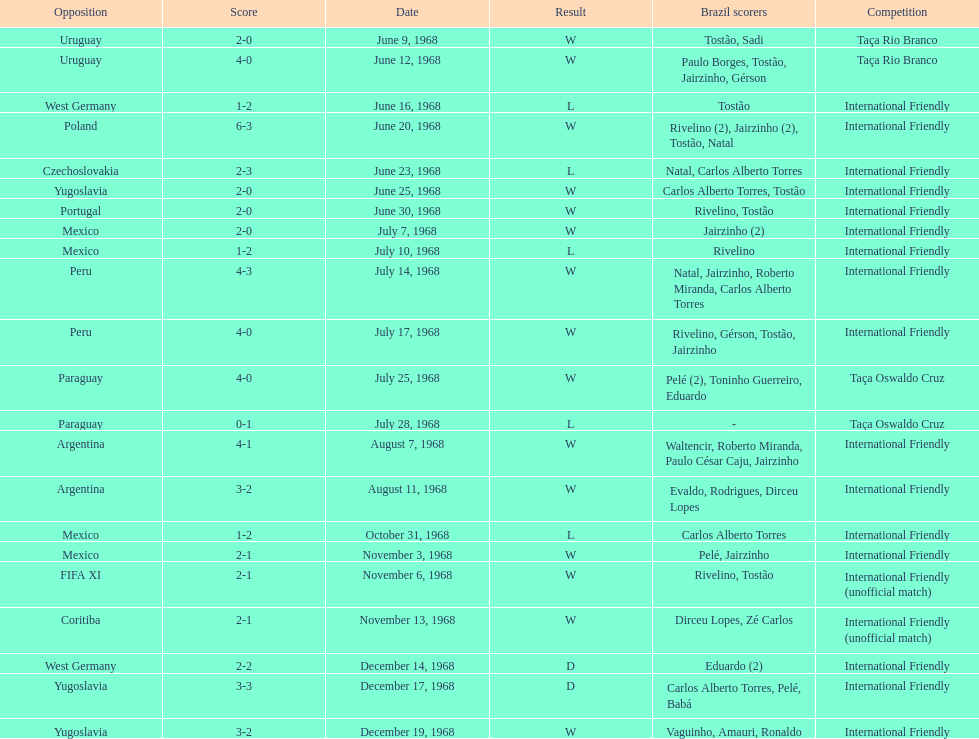What is the number of countries they have played? 11. 